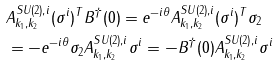Convert formula to latex. <formula><loc_0><loc_0><loc_500><loc_500>& A _ { k _ { 1 } , k _ { 2 } } ^ { S U ( 2 ) , i } ( \sigma ^ { i } ) ^ { T } B ^ { \dagger } ( 0 ) = e ^ { - i \theta } A _ { k _ { 1 } , k _ { 2 } } ^ { S U ( 2 ) , i } ( \sigma ^ { i } ) ^ { T } \sigma _ { 2 } \\ & = - e ^ { - i \theta } \sigma _ { 2 } A _ { k _ { 1 } , k _ { 2 } } ^ { S U ( 2 ) , i } \sigma ^ { i } = - B ^ { \dagger } ( 0 ) A _ { k _ { 1 } , k _ { 2 } } ^ { S U ( 2 ) , i } \sigma ^ { i }</formula> 